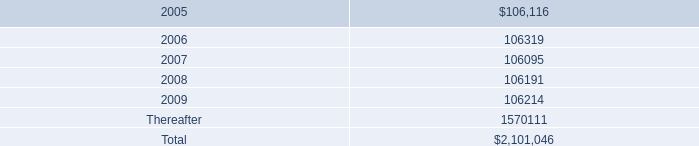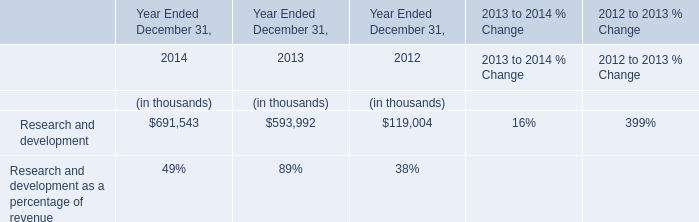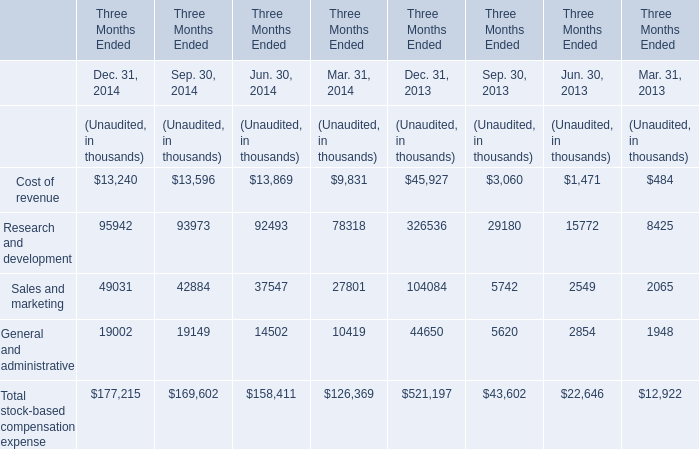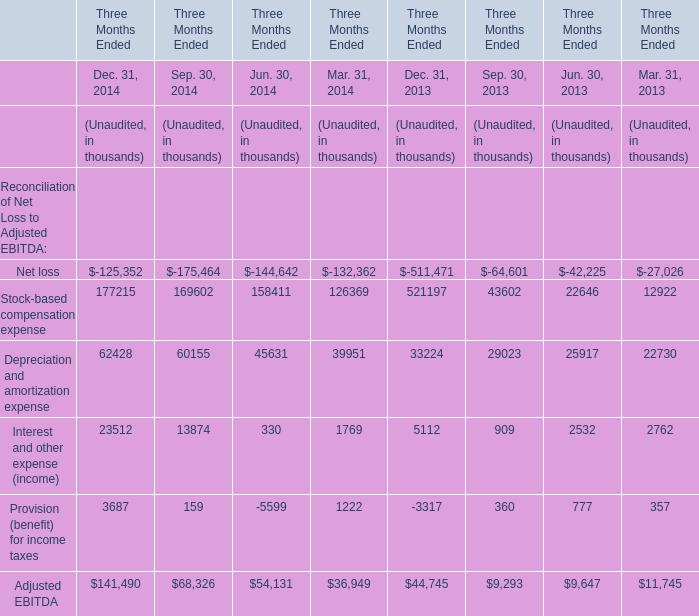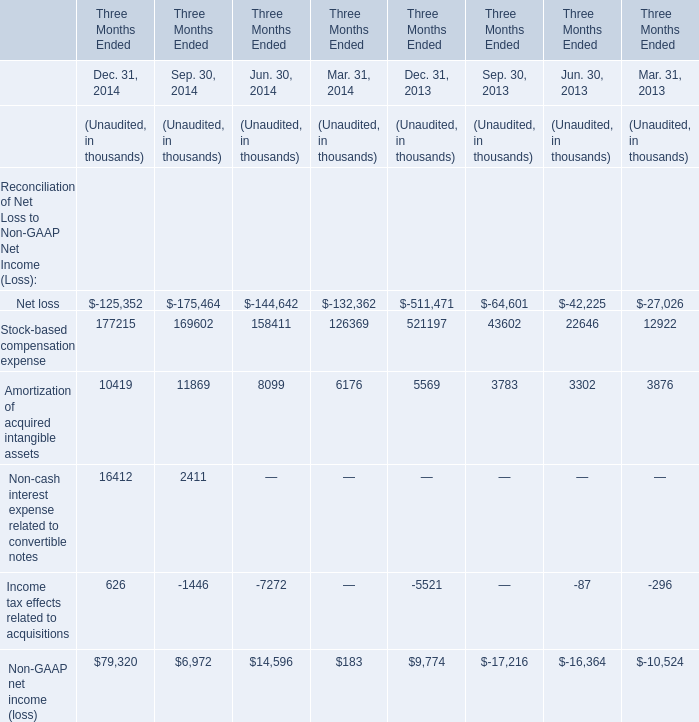Is the total amount of all elements in Dec.31,2014 greater than that in Dec.31,2013? 
Answer: No. 